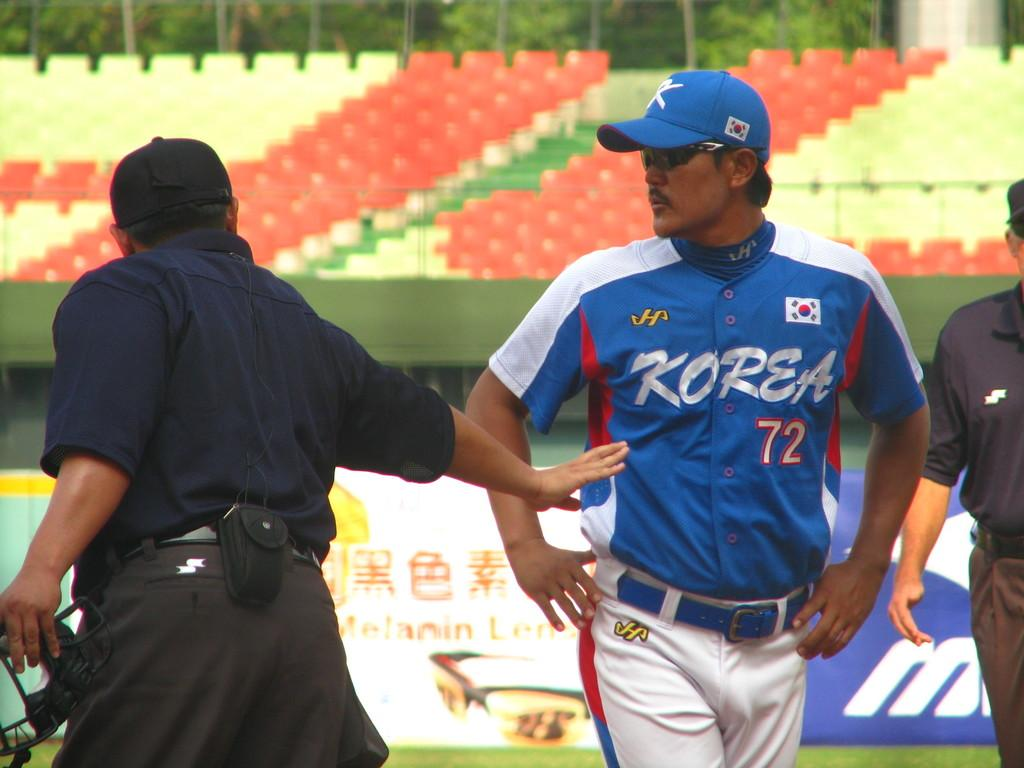<image>
Present a compact description of the photo's key features. a man from Korea that is next to an umpire 